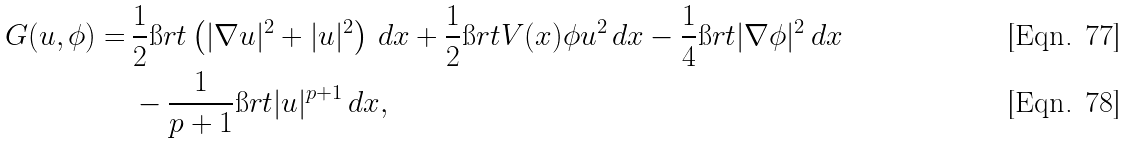Convert formula to latex. <formula><loc_0><loc_0><loc_500><loc_500>G ( u , \phi ) = & \, \frac { 1 } { 2 } \i r t \left ( | \nabla u | ^ { 2 } + | u | ^ { 2 } \right ) \, d x + \frac { 1 } { 2 } \i r t V ( x ) \phi u ^ { 2 } \, d x - \frac { 1 } { 4 } \i r t | \nabla \phi | ^ { 2 } \, d x \\ & \, - \frac { 1 } { p + 1 } \i r t | u | ^ { p + 1 } \, d x ,</formula> 